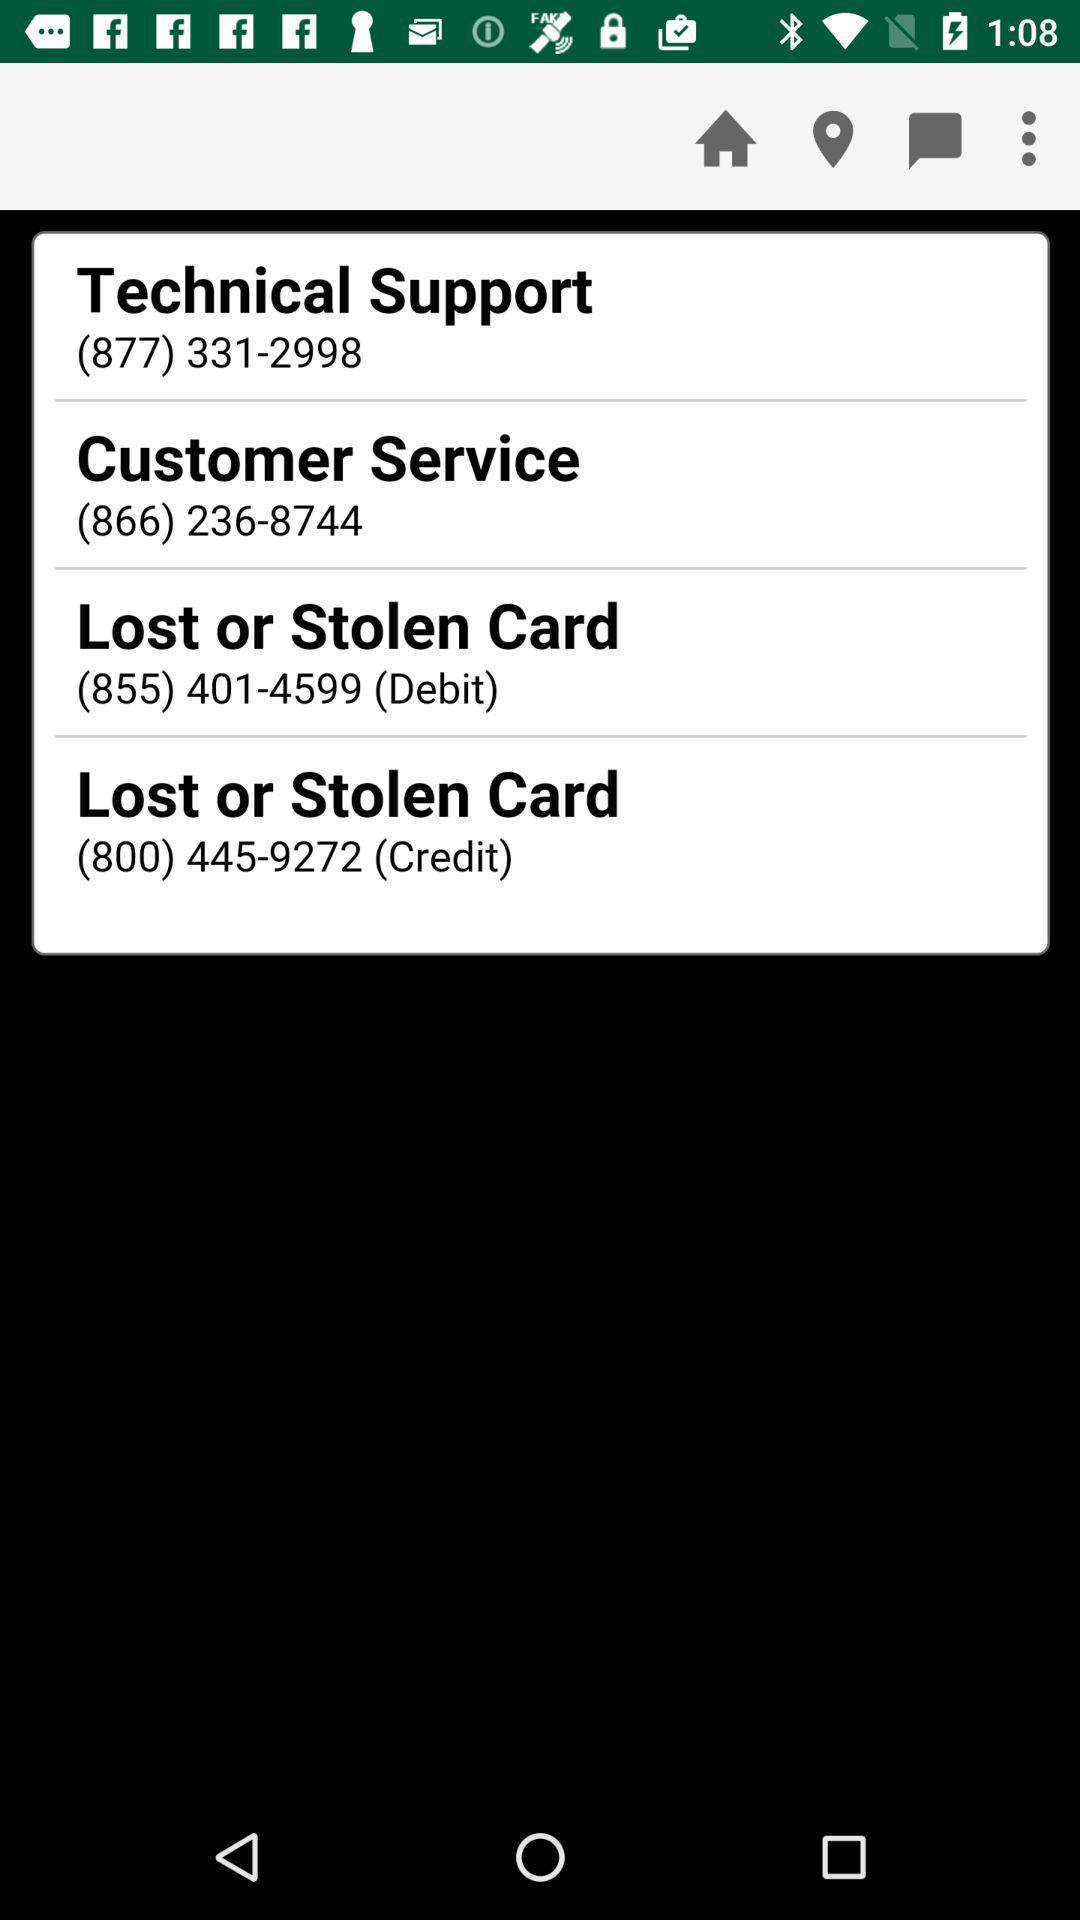What is the contact number for the support department to report a lost or stolen credit card? The contact number for the support department to report a lost or stolen credit card is (800) 445-9272. 